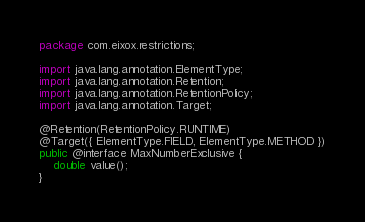<code> <loc_0><loc_0><loc_500><loc_500><_Java_>package com.eixox.restrictions;

import java.lang.annotation.ElementType;
import java.lang.annotation.Retention;
import java.lang.annotation.RetentionPolicy;
import java.lang.annotation.Target;

@Retention(RetentionPolicy.RUNTIME)
@Target({ ElementType.FIELD, ElementType.METHOD })
public @interface MaxNumberExclusive {
	double value();
}
</code> 